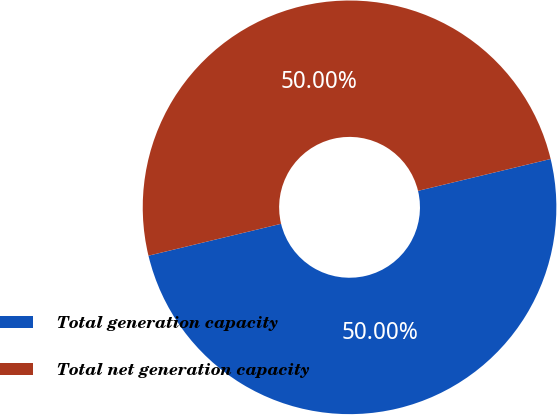Convert chart to OTSL. <chart><loc_0><loc_0><loc_500><loc_500><pie_chart><fcel>Total generation capacity<fcel>Total net generation capacity<nl><fcel>50.0%<fcel>50.0%<nl></chart> 